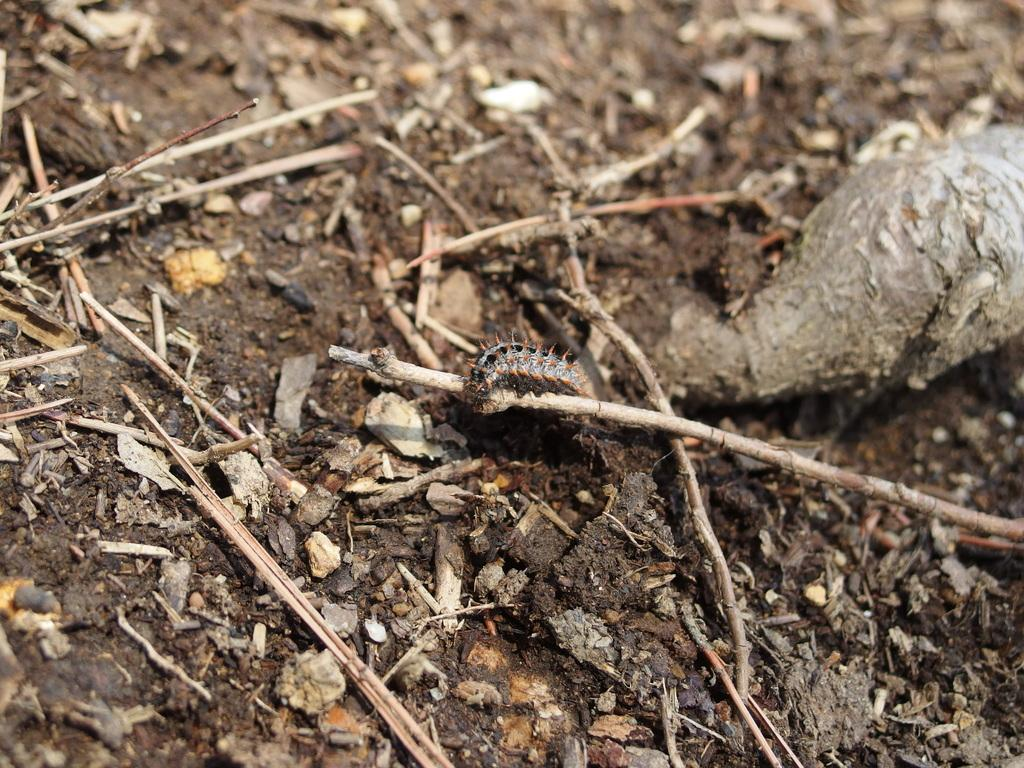What type of natural material can be seen in the image? There is soil in the image. What additional organic matter can be observed in the image? Dry leaves and dry grass are visible in the image. Can you describe the insect in the image? There is an insect on a wooden stick in the image. What type of button can be seen on the appliance in the image? There is no appliance or button present in the image. How does the exchange of goods occur in the image? There is no exchange of goods depicted in the image. 